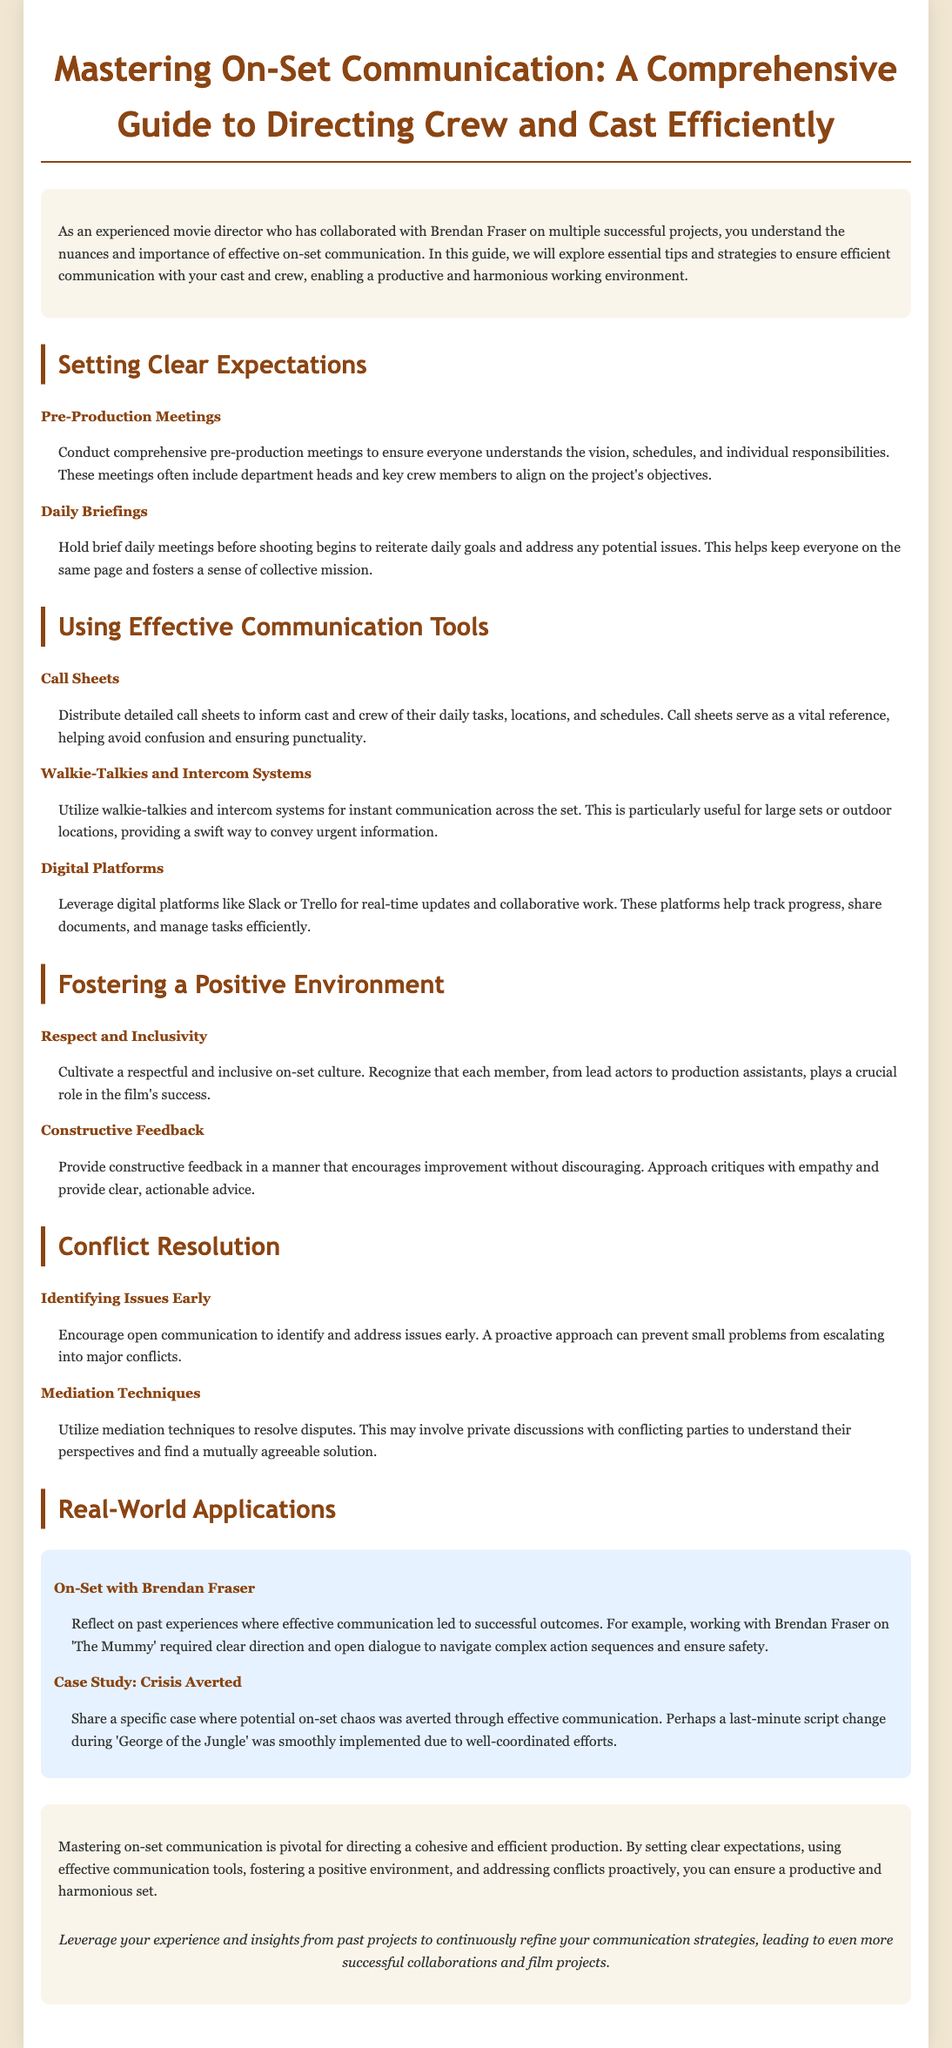What is the title of the guide? The title is presented prominently at the top of the document and outlines the main focus of the content.
Answer: Mastering On-Set Communication: A Comprehensive Guide to Directing Crew and Cast Efficiently Who is the target audience for this guide? The introduction specifies the intended audience, highlighting their experience level and past collaborations.
Answer: Experienced movie directors What tool is suggested for instant communication across the set? The document recommends specific tools to aid communication, particularly for larger sets.
Answer: Walkie-Talkies and Intercom Systems What should daily briefings address? The guide outlines the purpose of daily briefings in relation to on-set communication.
Answer: Daily goals and potential issues What type of feedback should directors provide? The guide emphasizes the manner in which feedback should be delivered to the crew and cast.
Answer: Constructive feedback What key issue does the section on conflict resolution emphasize? This section highlights an important aspect of resolving disputes among cast and crew members.
Answer: Identifying issues early What real-world example is provided about working with Brendan Fraser? The document includes a specific example to illustrate a communication success story in past projects.
Answer: Effective communication led to successful outcomes What is the main goal of mastering on-set communication? The conclusion summarizes the overarching aim of implementing the strategies outlined in the guide.
Answer: A productive and harmonious set What is a suggested digital platform for managing tasks? The guide mentions specific online tools to facilitate communication and task management on set.
Answer: Slack or Trello 